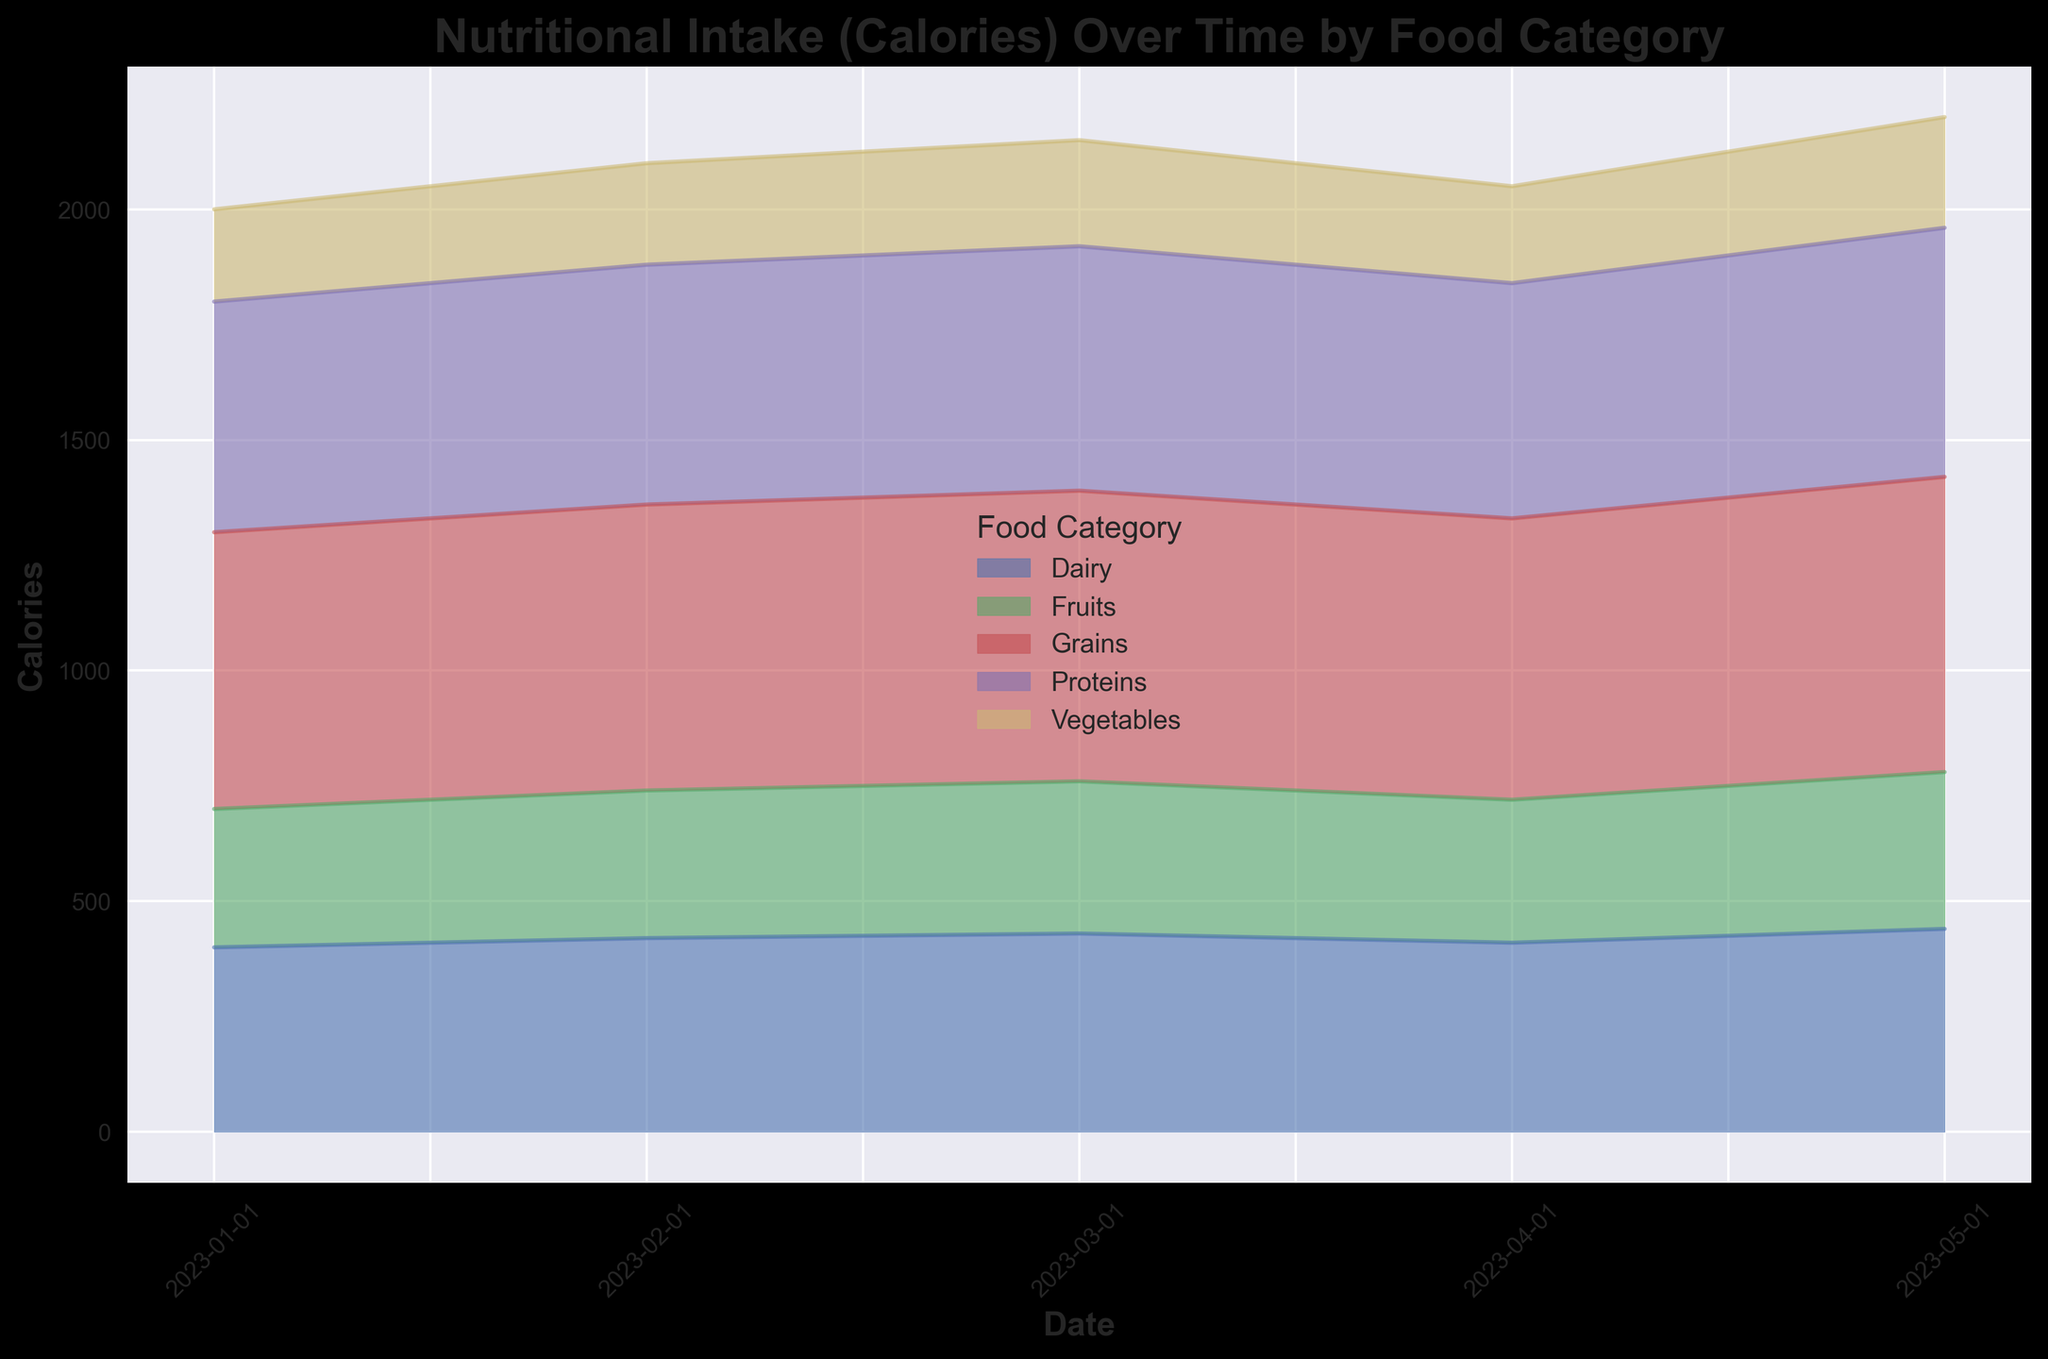Which Food Category has the highest nutritional intake (Calories) by the end of the period shown in the chart? By examining the area chart on the final date provided, observe which category has the largest area under the curve. The category with the most area represents the highest calorie intake.
Answer: Grains How does the calorie intake of Proteins compare between March 1, 2023, and April 1, 2023? Look at the vertical heights of the area under the "Proteins" category on the dates of March 1 and April 1. Compare these heights to understand which is higher and by how much.
Answer: Slightly higher in March What's the total calorie intake from Fruits across all provided dates? For each date, note the calorie intake for Fruits and then sum them up: 300 + 320 + 330 + 310 + 340 = 1600
Answer: 1600 On which date does the Dairy category show the lowest calorie intake? Look at the height of the "Dairy" section across all dates and determine the date where this value is the smallest.
Answer: April 1, 2023 Is the calorie intake for Vegetables generally increasing, decreasing, or stable over the period? Observe the trend line of the "Vegetables" category throughout the chart. Determine if the line slopes upwards, downwards, or remains relatively flat.
Answer: Increasing On which date is the total calorie intake from all food categories the highest? For each date, sum the caloric contributions from all categories visible on that date. Identify the date with the highest total sum.
Answer: May 1, 2023 Does the calorie intake from Grains exceed that from Proteins on January 1, 2023? Compare the areas of the "Grains" and "Proteins" sections on January 1. Note if the height of Grains is taller than that of Proteins.
Answer: Yes What is the difference in total calorie intake from Dairy between February 1, 2023, and May 1, 2023? Find the caloric values for Dairy on February 1 and May 1. Subtract the May value from the February value to get the difference: \(440 - 420 = 20\)
Answer: 20 Among all Food Categories, which two have the closest calorie intake values on March 1, 2023? Look at the values for all categories on March 1 and spot the two categories with the nearest values.
Answer: Fruits and Vegetables 